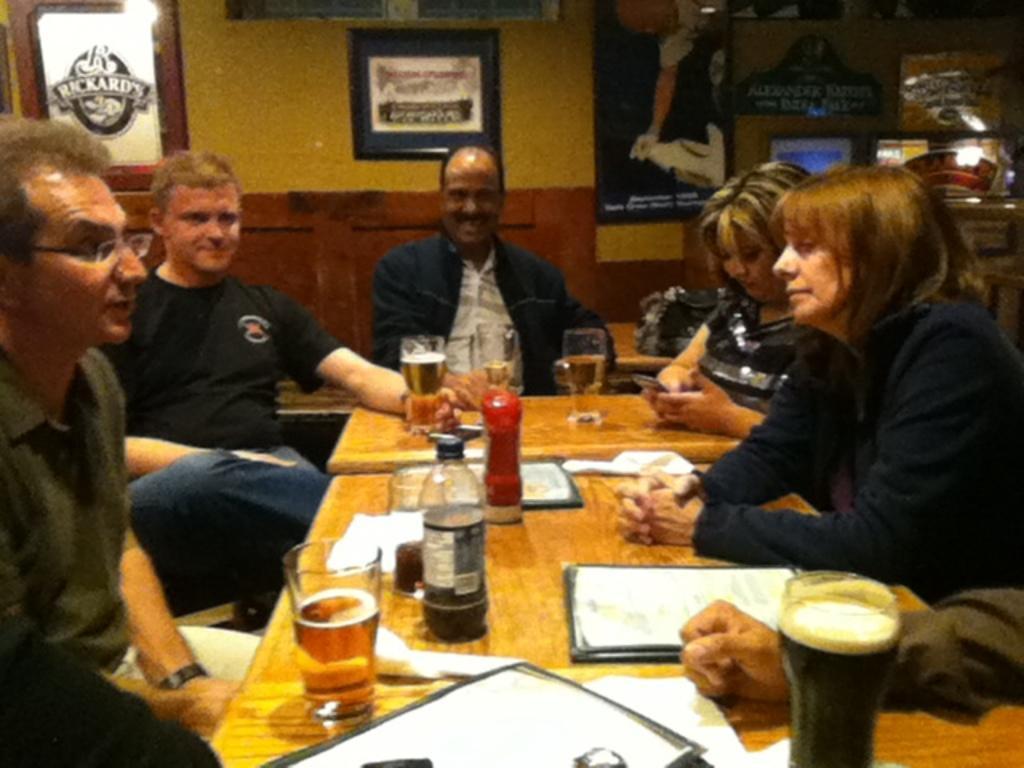Describe this image in one or two sentences. In this image there are five person sitting on the chair. On the table there is a paper,glass,bottle. At the a backside the frames are attached to the wall. 